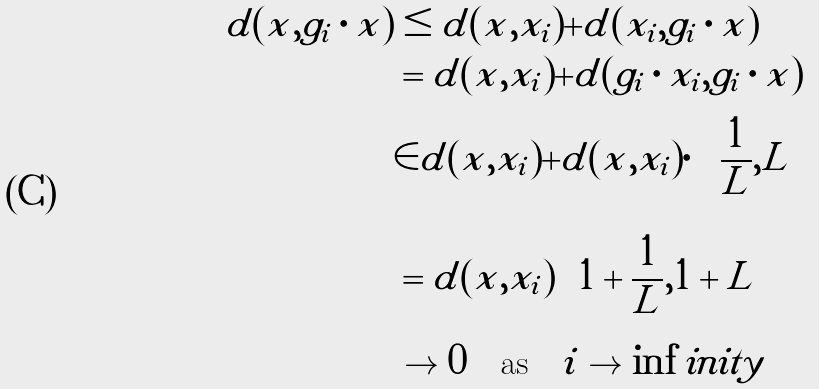Convert formula to latex. <formula><loc_0><loc_0><loc_500><loc_500>d ( x , g _ { i } \cdot x ) & \leq d ( x , x _ { i } ) + d ( x _ { i } , g _ { i } \cdot x ) \\ & = d ( x , x _ { i } ) + d ( g _ { i } \cdot x _ { i } , g _ { i } \cdot x ) \\ & \in d ( x , x _ { i } ) + d ( x , x _ { i } ) \cdot \left [ \frac { 1 } { L } , L \right ] \\ & = d ( x , x _ { i } ) \left [ 1 + \frac { 1 } { L } , 1 + L \right ] \\ & \to 0 \quad \text {as} \quad i \to \inf i n i t y</formula> 